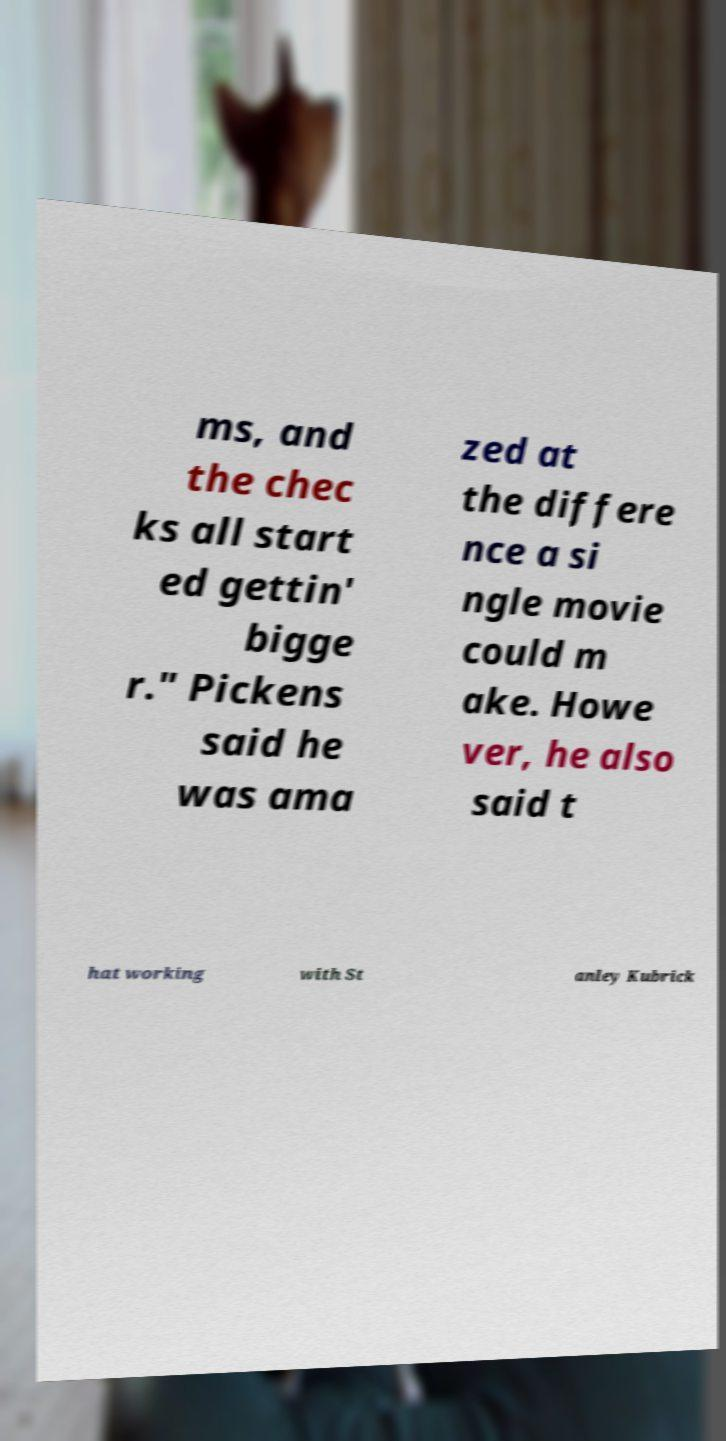There's text embedded in this image that I need extracted. Can you transcribe it verbatim? ms, and the chec ks all start ed gettin' bigge r." Pickens said he was ama zed at the differe nce a si ngle movie could m ake. Howe ver, he also said t hat working with St anley Kubrick 